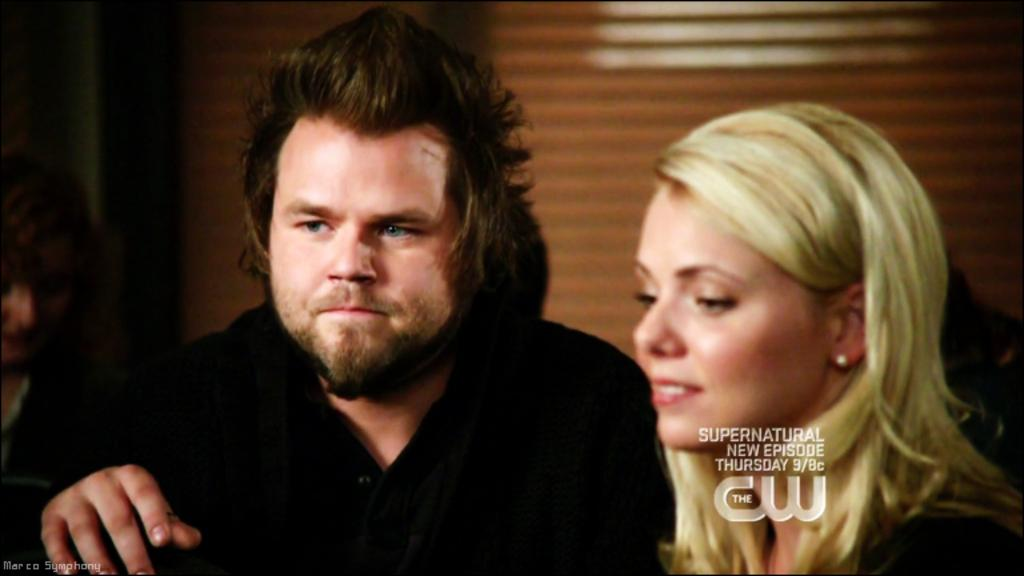How many people are present in the image? There is a man and a woman in the image. Can you describe the background of the image? The background of the image is blurred. Where is the text located in the image? The text is visible on the right side of the image. What type of kick is the man performing in the image? There is no kick being performed in the image; the man is simply standing or interacting with the woman. 